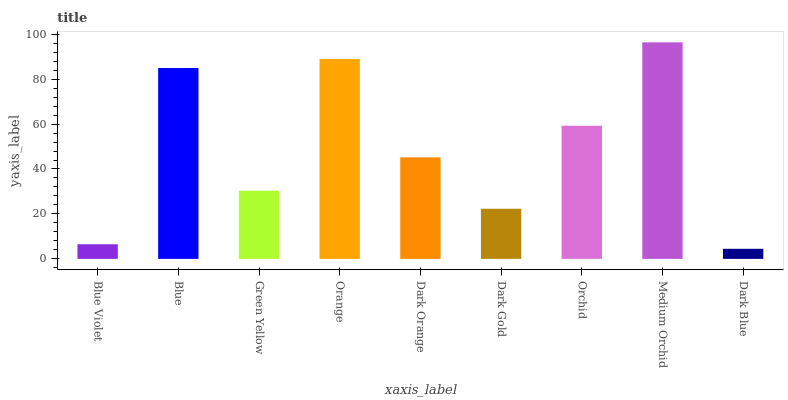Is Blue the minimum?
Answer yes or no. No. Is Blue the maximum?
Answer yes or no. No. Is Blue greater than Blue Violet?
Answer yes or no. Yes. Is Blue Violet less than Blue?
Answer yes or no. Yes. Is Blue Violet greater than Blue?
Answer yes or no. No. Is Blue less than Blue Violet?
Answer yes or no. No. Is Dark Orange the high median?
Answer yes or no. Yes. Is Dark Orange the low median?
Answer yes or no. Yes. Is Blue Violet the high median?
Answer yes or no. No. Is Orchid the low median?
Answer yes or no. No. 